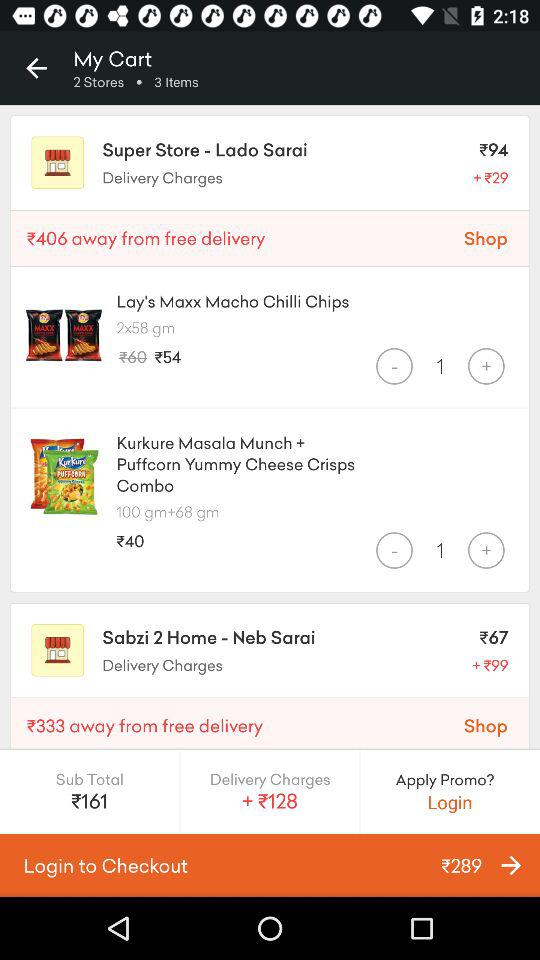How many items are there in the cart? There are 3 items in the cart. 